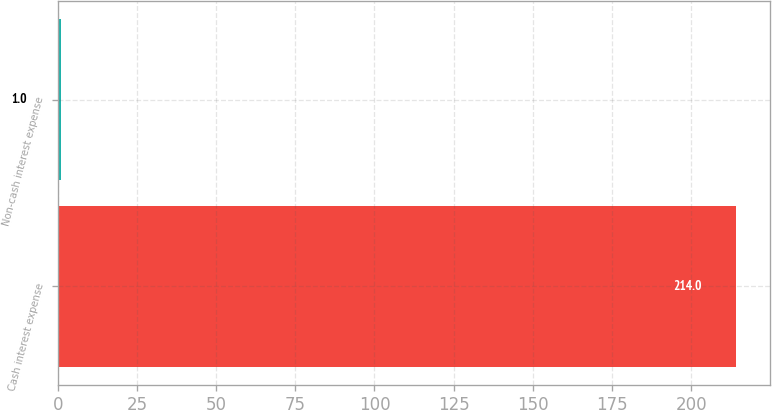<chart> <loc_0><loc_0><loc_500><loc_500><bar_chart><fcel>Cash interest expense<fcel>Non-cash interest expense<nl><fcel>214<fcel>1<nl></chart> 